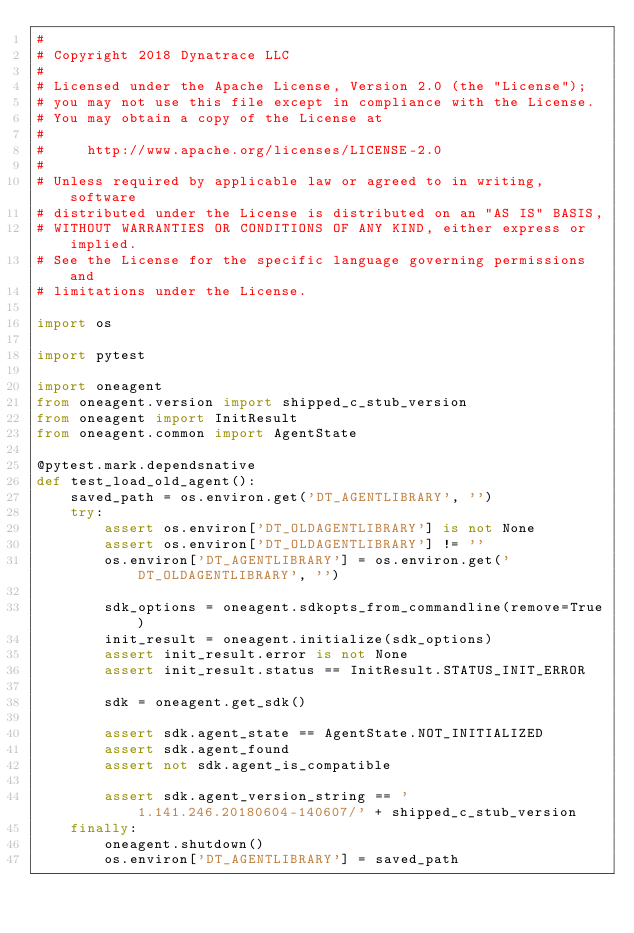Convert code to text. <code><loc_0><loc_0><loc_500><loc_500><_Python_>#
# Copyright 2018 Dynatrace LLC
#
# Licensed under the Apache License, Version 2.0 (the "License");
# you may not use this file except in compliance with the License.
# You may obtain a copy of the License at
#
#     http://www.apache.org/licenses/LICENSE-2.0
#
# Unless required by applicable law or agreed to in writing, software
# distributed under the License is distributed on an "AS IS" BASIS,
# WITHOUT WARRANTIES OR CONDITIONS OF ANY KIND, either express or implied.
# See the License for the specific language governing permissions and
# limitations under the License.

import os

import pytest

import oneagent
from oneagent.version import shipped_c_stub_version
from oneagent import InitResult
from oneagent.common import AgentState

@pytest.mark.dependsnative
def test_load_old_agent():
    saved_path = os.environ.get('DT_AGENTLIBRARY', '')
    try:
        assert os.environ['DT_OLDAGENTLIBRARY'] is not None
        assert os.environ['DT_OLDAGENTLIBRARY'] != ''
        os.environ['DT_AGENTLIBRARY'] = os.environ.get('DT_OLDAGENTLIBRARY', '')

        sdk_options = oneagent.sdkopts_from_commandline(remove=True)
        init_result = oneagent.initialize(sdk_options)
        assert init_result.error is not None
        assert init_result.status == InitResult.STATUS_INIT_ERROR

        sdk = oneagent.get_sdk()

        assert sdk.agent_state == AgentState.NOT_INITIALIZED
        assert sdk.agent_found
        assert not sdk.agent_is_compatible

        assert sdk.agent_version_string == '1.141.246.20180604-140607/' + shipped_c_stub_version
    finally:
        oneagent.shutdown()
        os.environ['DT_AGENTLIBRARY'] = saved_path
</code> 